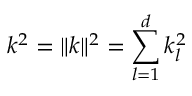Convert formula to latex. <formula><loc_0><loc_0><loc_500><loc_500>k ^ { 2 } = \| { k } \| ^ { 2 } = \sum _ { l = 1 } ^ { d } k _ { l } ^ { 2 }</formula> 